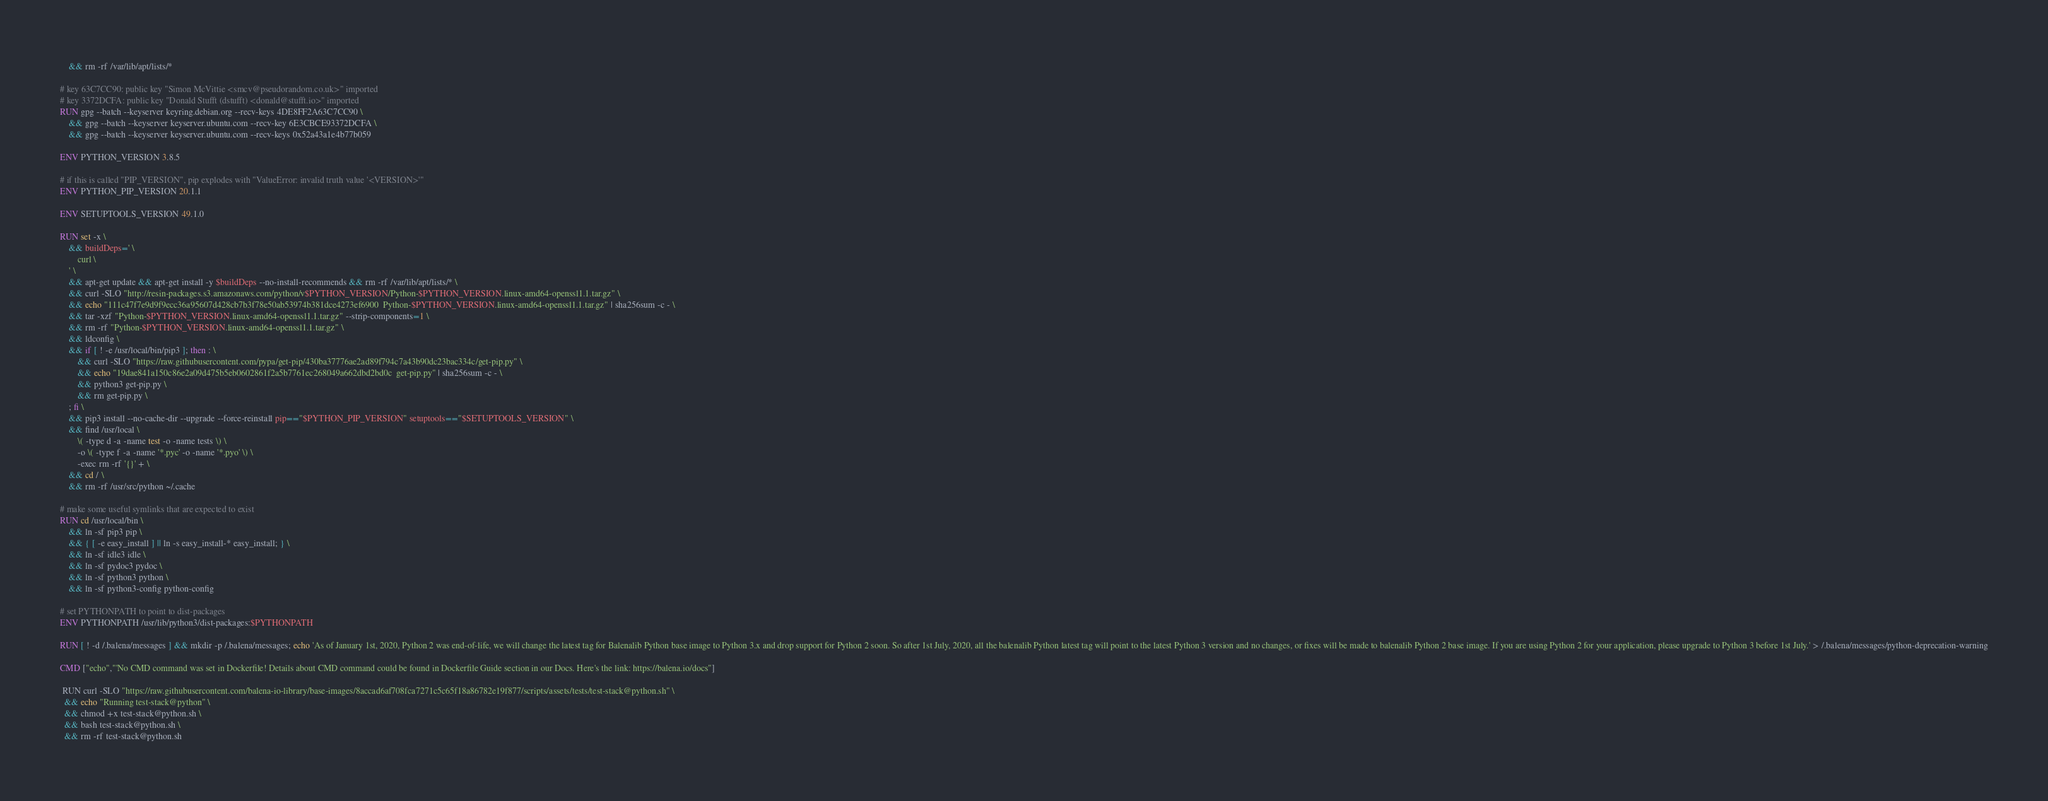Convert code to text. <code><loc_0><loc_0><loc_500><loc_500><_Dockerfile_>	&& rm -rf /var/lib/apt/lists/*

# key 63C7CC90: public key "Simon McVittie <smcv@pseudorandom.co.uk>" imported
# key 3372DCFA: public key "Donald Stufft (dstufft) <donald@stufft.io>" imported
RUN gpg --batch --keyserver keyring.debian.org --recv-keys 4DE8FF2A63C7CC90 \
	&& gpg --batch --keyserver keyserver.ubuntu.com --recv-key 6E3CBCE93372DCFA \
	&& gpg --batch --keyserver keyserver.ubuntu.com --recv-keys 0x52a43a1e4b77b059

ENV PYTHON_VERSION 3.8.5

# if this is called "PIP_VERSION", pip explodes with "ValueError: invalid truth value '<VERSION>'"
ENV PYTHON_PIP_VERSION 20.1.1

ENV SETUPTOOLS_VERSION 49.1.0

RUN set -x \
	&& buildDeps=' \
		curl \
	' \
	&& apt-get update && apt-get install -y $buildDeps --no-install-recommends && rm -rf /var/lib/apt/lists/* \
	&& curl -SLO "http://resin-packages.s3.amazonaws.com/python/v$PYTHON_VERSION/Python-$PYTHON_VERSION.linux-amd64-openssl1.1.tar.gz" \
	&& echo "111c47f7e9d9f9ecc36a95607d428cb7b3f78e50ab53974b381dce4273ef6900  Python-$PYTHON_VERSION.linux-amd64-openssl1.1.tar.gz" | sha256sum -c - \
	&& tar -xzf "Python-$PYTHON_VERSION.linux-amd64-openssl1.1.tar.gz" --strip-components=1 \
	&& rm -rf "Python-$PYTHON_VERSION.linux-amd64-openssl1.1.tar.gz" \
	&& ldconfig \
	&& if [ ! -e /usr/local/bin/pip3 ]; then : \
		&& curl -SLO "https://raw.githubusercontent.com/pypa/get-pip/430ba37776ae2ad89f794c7a43b90dc23bac334c/get-pip.py" \
		&& echo "19dae841a150c86e2a09d475b5eb0602861f2a5b7761ec268049a662dbd2bd0c  get-pip.py" | sha256sum -c - \
		&& python3 get-pip.py \
		&& rm get-pip.py \
	; fi \
	&& pip3 install --no-cache-dir --upgrade --force-reinstall pip=="$PYTHON_PIP_VERSION" setuptools=="$SETUPTOOLS_VERSION" \
	&& find /usr/local \
		\( -type d -a -name test -o -name tests \) \
		-o \( -type f -a -name '*.pyc' -o -name '*.pyo' \) \
		-exec rm -rf '{}' + \
	&& cd / \
	&& rm -rf /usr/src/python ~/.cache

# make some useful symlinks that are expected to exist
RUN cd /usr/local/bin \
	&& ln -sf pip3 pip \
	&& { [ -e easy_install ] || ln -s easy_install-* easy_install; } \
	&& ln -sf idle3 idle \
	&& ln -sf pydoc3 pydoc \
	&& ln -sf python3 python \
	&& ln -sf python3-config python-config

# set PYTHONPATH to point to dist-packages
ENV PYTHONPATH /usr/lib/python3/dist-packages:$PYTHONPATH

RUN [ ! -d /.balena/messages ] && mkdir -p /.balena/messages; echo 'As of January 1st, 2020, Python 2 was end-of-life, we will change the latest tag for Balenalib Python base image to Python 3.x and drop support for Python 2 soon. So after 1st July, 2020, all the balenalib Python latest tag will point to the latest Python 3 version and no changes, or fixes will be made to balenalib Python 2 base image. If you are using Python 2 for your application, please upgrade to Python 3 before 1st July.' > /.balena/messages/python-deprecation-warning

CMD ["echo","'No CMD command was set in Dockerfile! Details about CMD command could be found in Dockerfile Guide section in our Docs. Here's the link: https://balena.io/docs"]

 RUN curl -SLO "https://raw.githubusercontent.com/balena-io-library/base-images/8accad6af708fca7271c5c65f18a86782e19f877/scripts/assets/tests/test-stack@python.sh" \
  && echo "Running test-stack@python" \
  && chmod +x test-stack@python.sh \
  && bash test-stack@python.sh \
  && rm -rf test-stack@python.sh 
</code> 